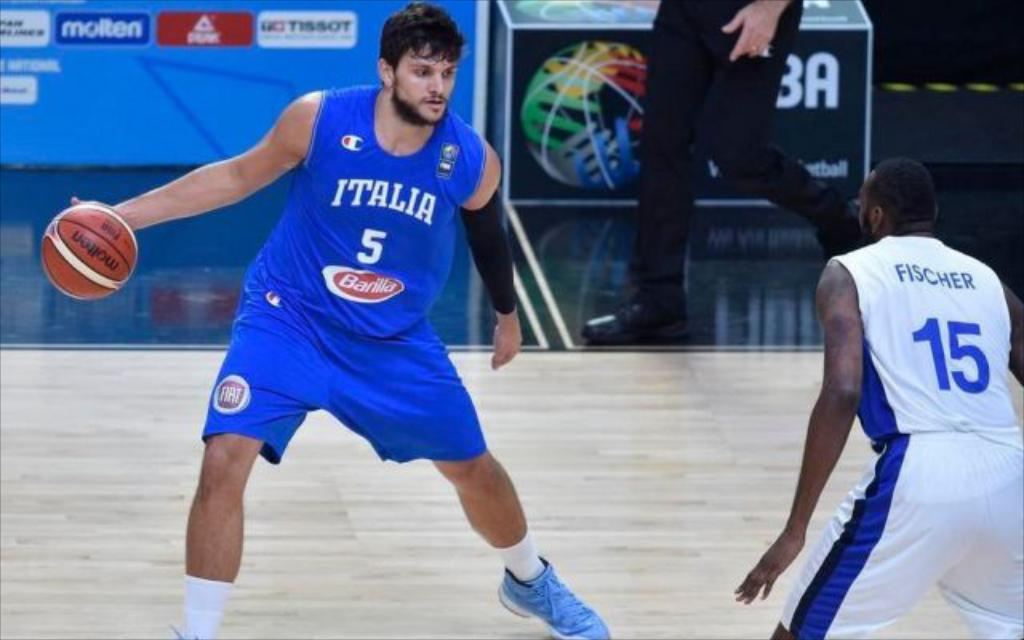<image>
Write a terse but informative summary of the picture. Two men are playing baseball by a referee and the player with the ball has an Italia jersey. 